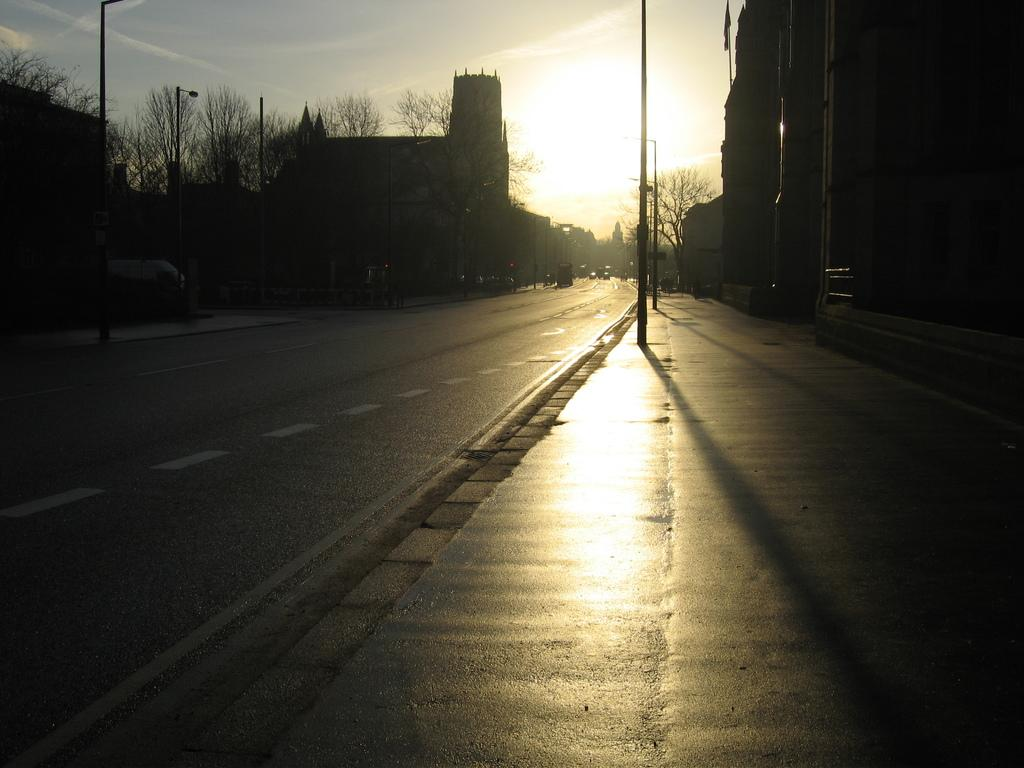What is the main feature of the image? There is a road in the image. What can be seen alongside the road? There are street lights in the image. What is visible in the background of the image? There are buildings, trees, and the sky in the background of the image. Can the sun be seen in the image? Yes, the sun is observable in the sky. What type of stocking is hanging from the street light in the image? There is no stocking hanging from the street light in the image. Can you describe the wave pattern in the image? There is no wave pattern present in the image. 